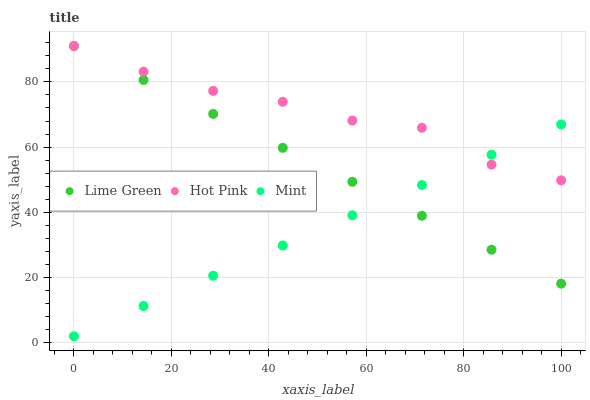Does Mint have the minimum area under the curve?
Answer yes or no. Yes. Does Hot Pink have the maximum area under the curve?
Answer yes or no. Yes. Does Lime Green have the minimum area under the curve?
Answer yes or no. No. Does Lime Green have the maximum area under the curve?
Answer yes or no. No. Is Mint the smoothest?
Answer yes or no. Yes. Is Hot Pink the roughest?
Answer yes or no. Yes. Is Lime Green the smoothest?
Answer yes or no. No. Is Lime Green the roughest?
Answer yes or no. No. Does Mint have the lowest value?
Answer yes or no. Yes. Does Lime Green have the lowest value?
Answer yes or no. No. Does Lime Green have the highest value?
Answer yes or no. Yes. Does Hot Pink intersect Mint?
Answer yes or no. Yes. Is Hot Pink less than Mint?
Answer yes or no. No. Is Hot Pink greater than Mint?
Answer yes or no. No. 